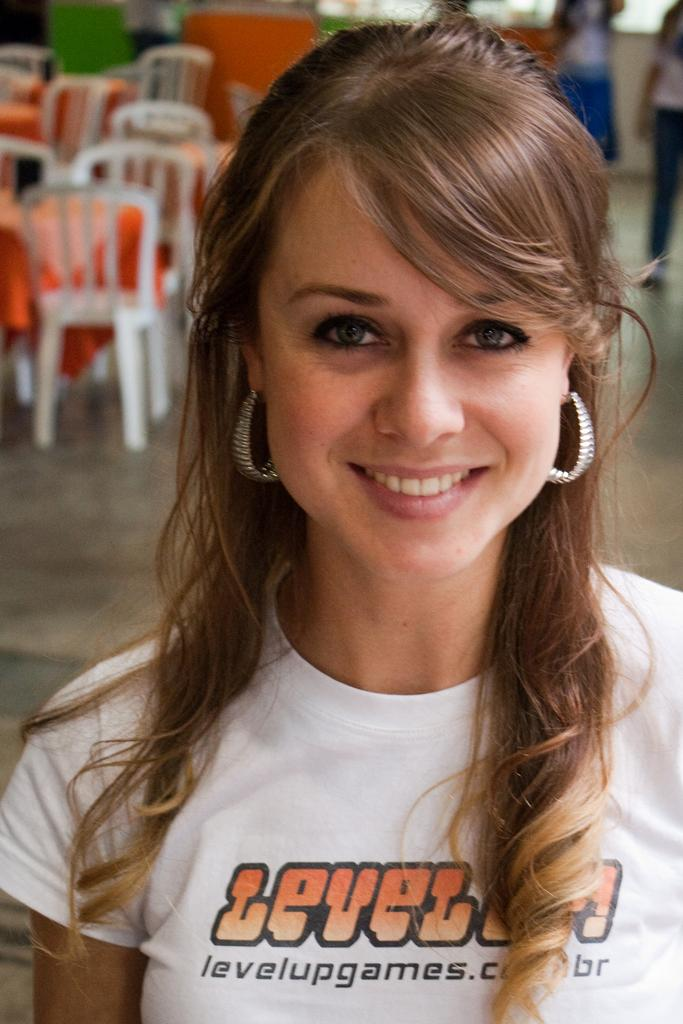Who is present in the image? There is a lady in the image. What type of furniture can be seen in the image? Chairs and tables are present in the image. What type of cloth is being used to shock the lady in the image? There is no cloth or shocking action present in the image. 